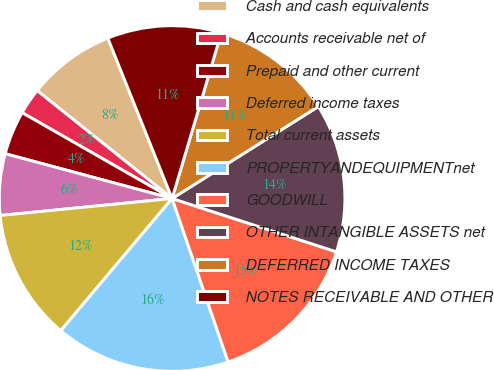<chart> <loc_0><loc_0><loc_500><loc_500><pie_chart><fcel>Cash and cash equivalents<fcel>Accounts receivable net of<fcel>Prepaid and other current<fcel>Deferred income taxes<fcel>Total current assets<fcel>PROPERTYANDEQUIPMENTnet<fcel>GOODWILL<fcel>OTHER INTANGIBLE ASSETS net<fcel>DEFERRED INCOME TAXES<fcel>NOTES RECEIVABLE AND OTHER<nl><fcel>8.2%<fcel>2.46%<fcel>4.1%<fcel>5.74%<fcel>12.29%<fcel>16.39%<fcel>14.75%<fcel>13.93%<fcel>11.47%<fcel>10.66%<nl></chart> 